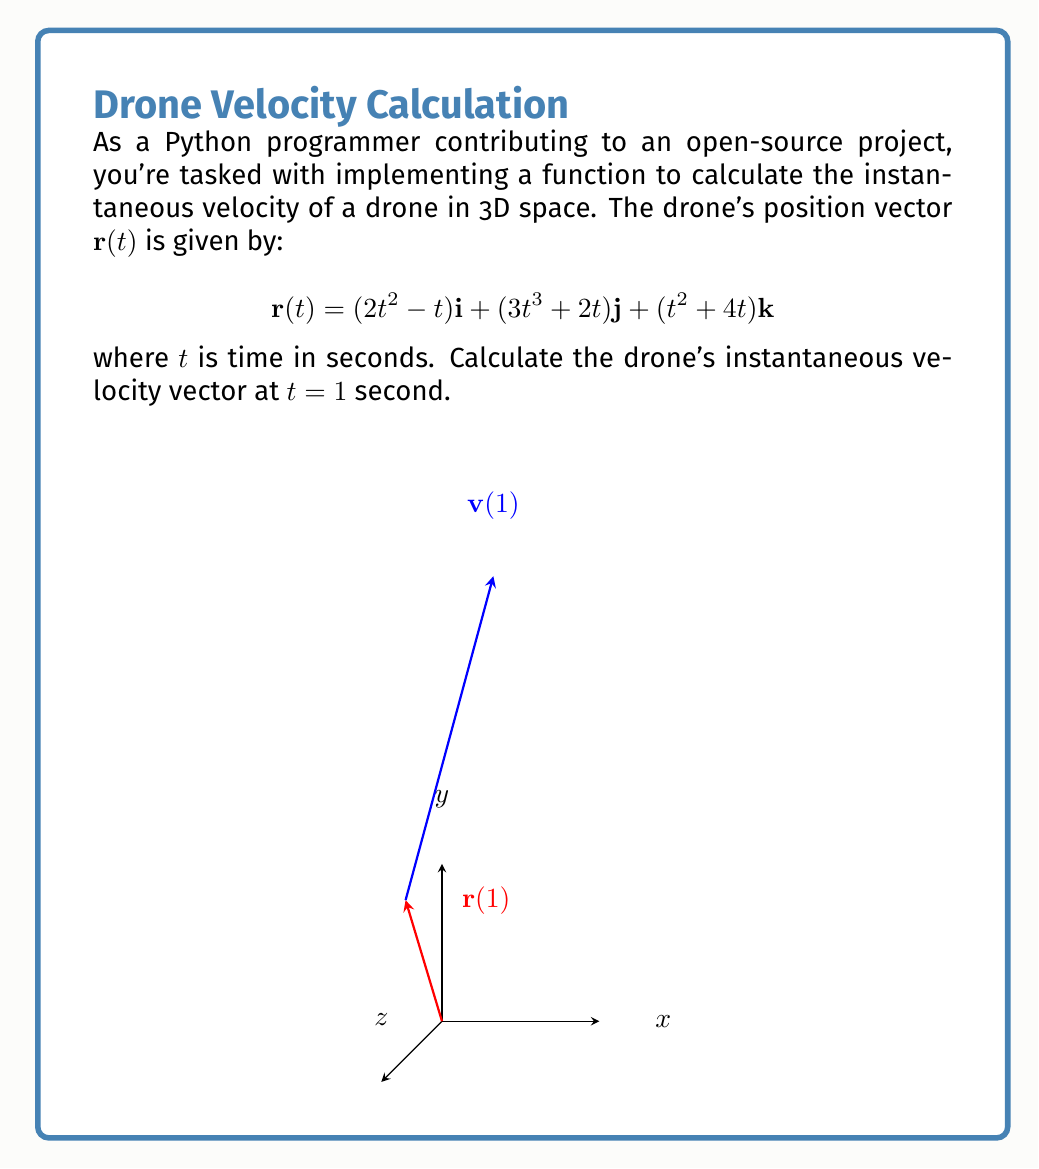Can you solve this math problem? To find the instantaneous velocity vector, we need to differentiate the position vector $\mathbf{r}(t)$ with respect to time. Let's break it down step-by-step:

1) The velocity vector $\mathbf{v}(t)$ is the derivative of the position vector:

   $$\mathbf{v}(t) = \frac{d\mathbf{r}(t)}{dt}$$

2) Let's differentiate each component:

   For $x$-component: $\frac{d}{dt}(2t^2 - t) = 4t - 1$
   
   For $y$-component: $\frac{d}{dt}(3t^3 + 2t) = 9t^2 + 2$
   
   For $z$-component: $\frac{d}{dt}(t^2 + 4t) = 2t + 4$

3) Therefore, the velocity vector is:

   $$\mathbf{v}(t) = (4t - 1)\mathbf{i} + (9t^2 + 2)\mathbf{j} + (2t + 4)\mathbf{k}$$

4) To find the instantaneous velocity at $t = 1$, we substitute $t = 1$ into $\mathbf{v}(t)$:

   $$\mathbf{v}(1) = (4(1) - 1)\mathbf{i} + (9(1)^2 + 2)\mathbf{j} + (2(1) + 4)\mathbf{k}$$

5) Simplifying:

   $$\mathbf{v}(1) = 3\mathbf{i} + 11\mathbf{j} + 6\mathbf{k}$$

This vector represents the instantaneous velocity of the drone at $t = 1$ second.
Answer: $3\mathbf{i} + 11\mathbf{j} + 6\mathbf{k}$ 